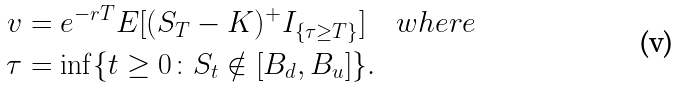<formula> <loc_0><loc_0><loc_500><loc_500>v & = e ^ { - r T } E [ ( S _ { T } - K ) ^ { + } I _ { \{ \tau \geq T \} } ] \quad w h e r e \\ \tau & = \inf \{ t \geq 0 \colon S _ { t } \notin [ B _ { d } , B _ { u } ] \} .</formula> 